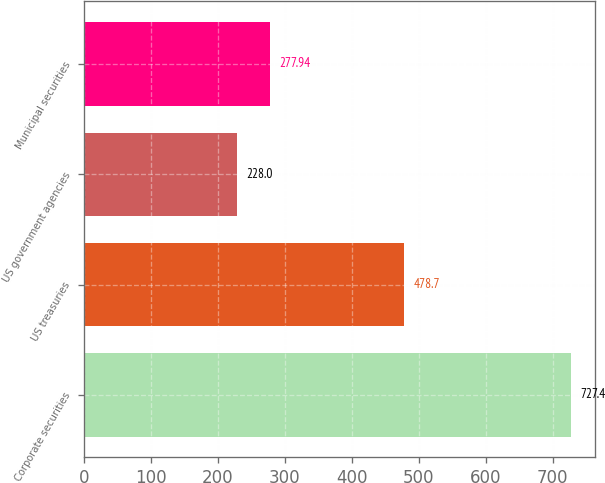Convert chart. <chart><loc_0><loc_0><loc_500><loc_500><bar_chart><fcel>Corporate securities<fcel>US treasuries<fcel>US government agencies<fcel>Municipal securities<nl><fcel>727.4<fcel>478.7<fcel>228<fcel>277.94<nl></chart> 